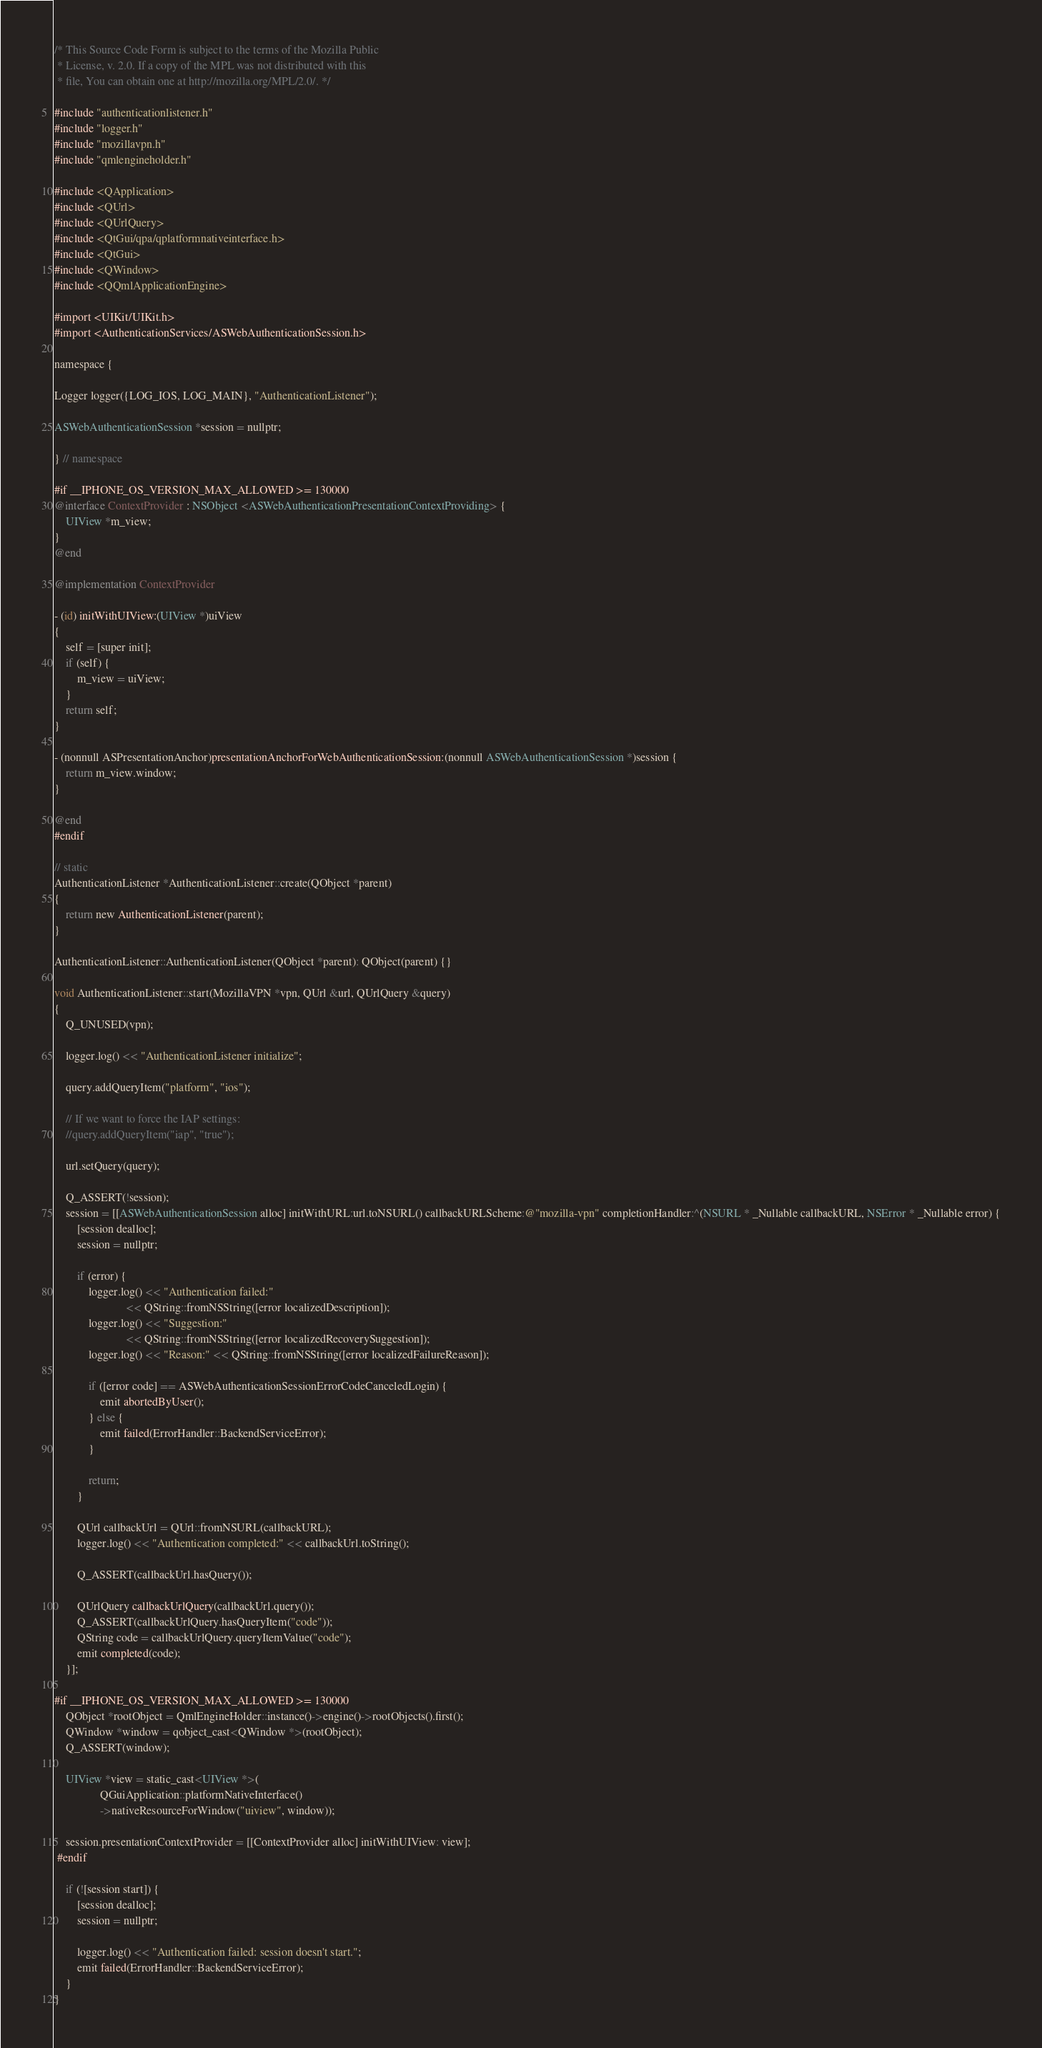<code> <loc_0><loc_0><loc_500><loc_500><_ObjectiveC_>/* This Source Code Form is subject to the terms of the Mozilla Public
 * License, v. 2.0. If a copy of the MPL was not distributed with this
 * file, You can obtain one at http://mozilla.org/MPL/2.0/. */

#include "authenticationlistener.h"
#include "logger.h"
#include "mozillavpn.h"
#include "qmlengineholder.h"

#include <QApplication>
#include <QUrl>
#include <QUrlQuery>
#include <QtGui/qpa/qplatformnativeinterface.h>
#include <QtGui>
#include <QWindow>
#include <QQmlApplicationEngine>

#import <UIKit/UIKit.h>
#import <AuthenticationServices/ASWebAuthenticationSession.h>

namespace {

Logger logger({LOG_IOS, LOG_MAIN}, "AuthenticationListener");

ASWebAuthenticationSession *session = nullptr;

} // namespace

#if __IPHONE_OS_VERSION_MAX_ALLOWED >= 130000
@interface ContextProvider : NSObject <ASWebAuthenticationPresentationContextProviding> {
    UIView *m_view;
}
@end

@implementation ContextProvider

- (id) initWithUIView:(UIView *)uiView
{
    self = [super init];
    if (self) {
        m_view = uiView;
    }
    return self;
}

- (nonnull ASPresentationAnchor)presentationAnchorForWebAuthenticationSession:(nonnull ASWebAuthenticationSession *)session {
    return m_view.window;
}

@end
#endif

// static
AuthenticationListener *AuthenticationListener::create(QObject *parent)
{
    return new AuthenticationListener(parent);
}

AuthenticationListener::AuthenticationListener(QObject *parent): QObject(parent) {}

void AuthenticationListener::start(MozillaVPN *vpn, QUrl &url, QUrlQuery &query)
{
    Q_UNUSED(vpn);

    logger.log() << "AuthenticationListener initialize";

    query.addQueryItem("platform", "ios");

    // If we want to force the IAP settings:
    //query.addQueryItem("iap", "true");

    url.setQuery(query);

    Q_ASSERT(!session);
    session = [[ASWebAuthenticationSession alloc] initWithURL:url.toNSURL() callbackURLScheme:@"mozilla-vpn" completionHandler:^(NSURL * _Nullable callbackURL, NSError * _Nullable error) {
        [session dealloc];
        session = nullptr;

        if (error) {
            logger.log() << "Authentication failed:"
                         << QString::fromNSString([error localizedDescription]);
            logger.log() << "Suggestion:"
                         << QString::fromNSString([error localizedRecoverySuggestion]);
            logger.log() << "Reason:" << QString::fromNSString([error localizedFailureReason]);

            if ([error code] == ASWebAuthenticationSessionErrorCodeCanceledLogin) {
                emit abortedByUser();
            } else {
                emit failed(ErrorHandler::BackendServiceError);
            }

            return;
        }

        QUrl callbackUrl = QUrl::fromNSURL(callbackURL);
        logger.log() << "Authentication completed:" << callbackUrl.toString();

        Q_ASSERT(callbackUrl.hasQuery());

        QUrlQuery callbackUrlQuery(callbackUrl.query());
        Q_ASSERT(callbackUrlQuery.hasQueryItem("code"));
        QString code = callbackUrlQuery.queryItemValue("code");
        emit completed(code);
    }];

#if __IPHONE_OS_VERSION_MAX_ALLOWED >= 130000
    QObject *rootObject = QmlEngineHolder::instance()->engine()->rootObjects().first();
    QWindow *window = qobject_cast<QWindow *>(rootObject);
    Q_ASSERT(window);

    UIView *view = static_cast<UIView *>(
                QGuiApplication::platformNativeInterface()
                ->nativeResourceForWindow("uiview", window));

    session.presentationContextProvider = [[ContextProvider alloc] initWithUIView: view];
 #endif

    if (![session start]) {
        [session dealloc];
        session = nullptr;

        logger.log() << "Authentication failed: session doesn't start.";
        emit failed(ErrorHandler::BackendServiceError);
    }
}
</code> 